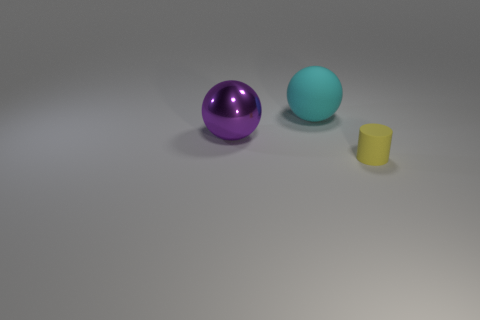Subtract 1 spheres. How many spheres are left? 1 Add 3 small red metallic blocks. How many objects exist? 6 Subtract all purple spheres. How many spheres are left? 1 Add 3 green cylinders. How many green cylinders exist? 3 Subtract 0 cyan cubes. How many objects are left? 3 Subtract all cylinders. How many objects are left? 2 Subtract all blue spheres. Subtract all green blocks. How many spheres are left? 2 Subtract all gray cubes. How many purple balls are left? 1 Subtract all big purple rubber objects. Subtract all large things. How many objects are left? 1 Add 1 large cyan rubber balls. How many large cyan rubber balls are left? 2 